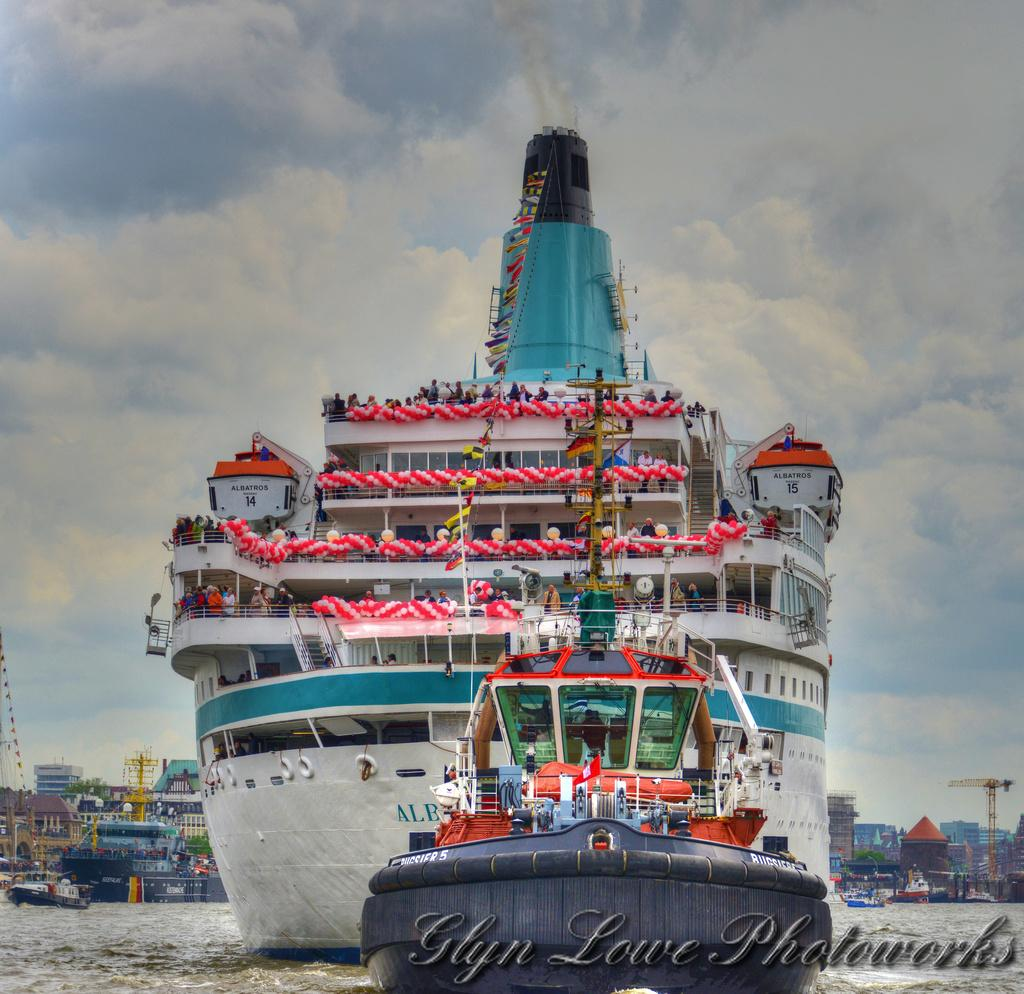What can be seen on the water in the image? There are ships on the water in the image. What type of equipment is present in the image? There are construction cranes in the image. What type of structures are visible in the image? There are buildings in the image. What is visible in the background of the image? The sky is visible in the background of the image. What can be seen in the sky? There are clouds in the sky. What type of amusement can be seen in the stomach of the person in the image? There is no person present in the image, and therefore no stomach or amusement can be observed. What type of underwear is visible on the construction cranes in the image? There is no underwear present in the image; the construction cranes are not wearing any clothing. 